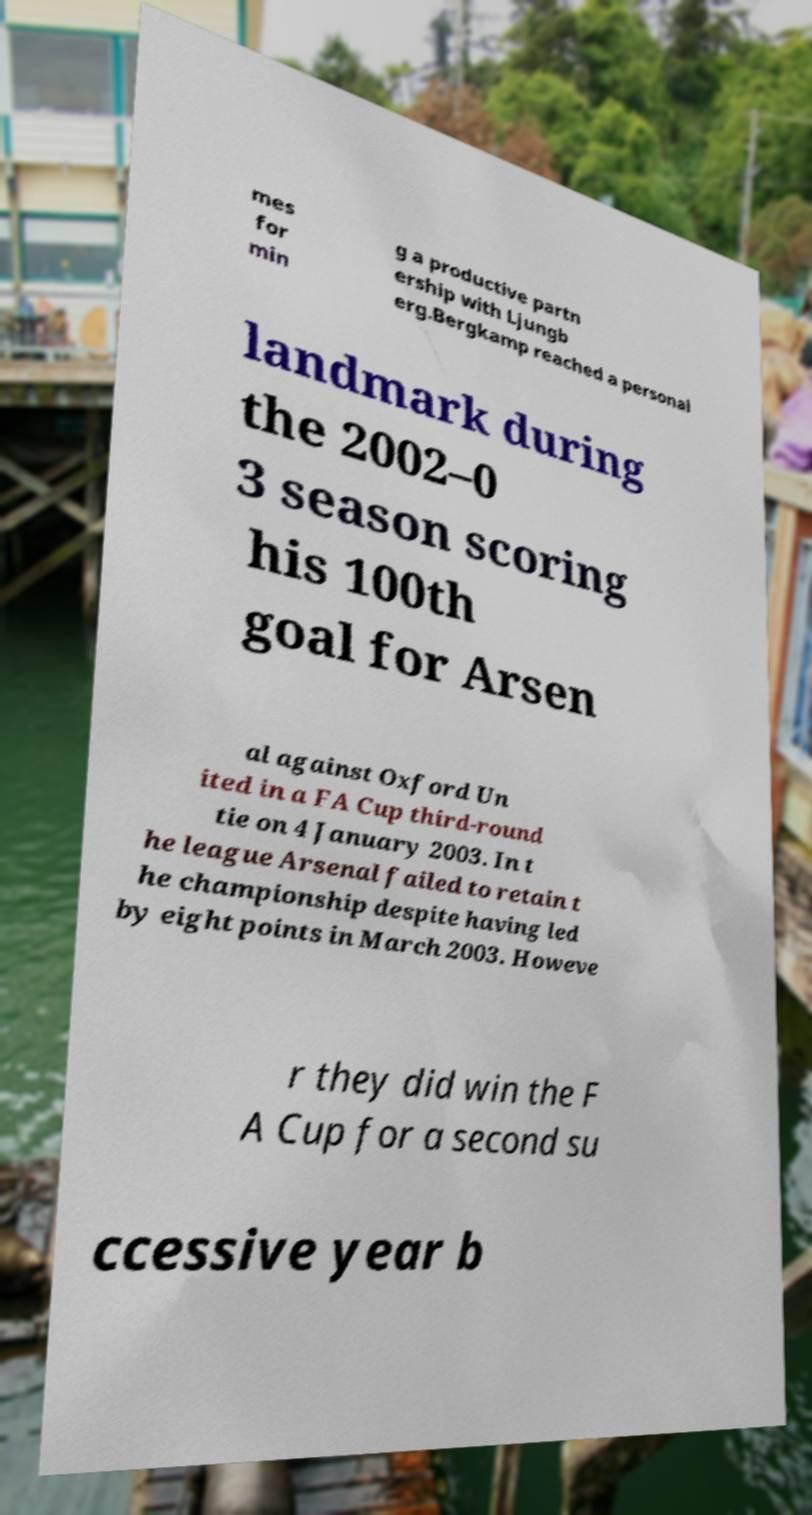Please identify and transcribe the text found in this image. mes for min g a productive partn ership with Ljungb erg.Bergkamp reached a personal landmark during the 2002–0 3 season scoring his 100th goal for Arsen al against Oxford Un ited in a FA Cup third-round tie on 4 January 2003. In t he league Arsenal failed to retain t he championship despite having led by eight points in March 2003. Howeve r they did win the F A Cup for a second su ccessive year b 